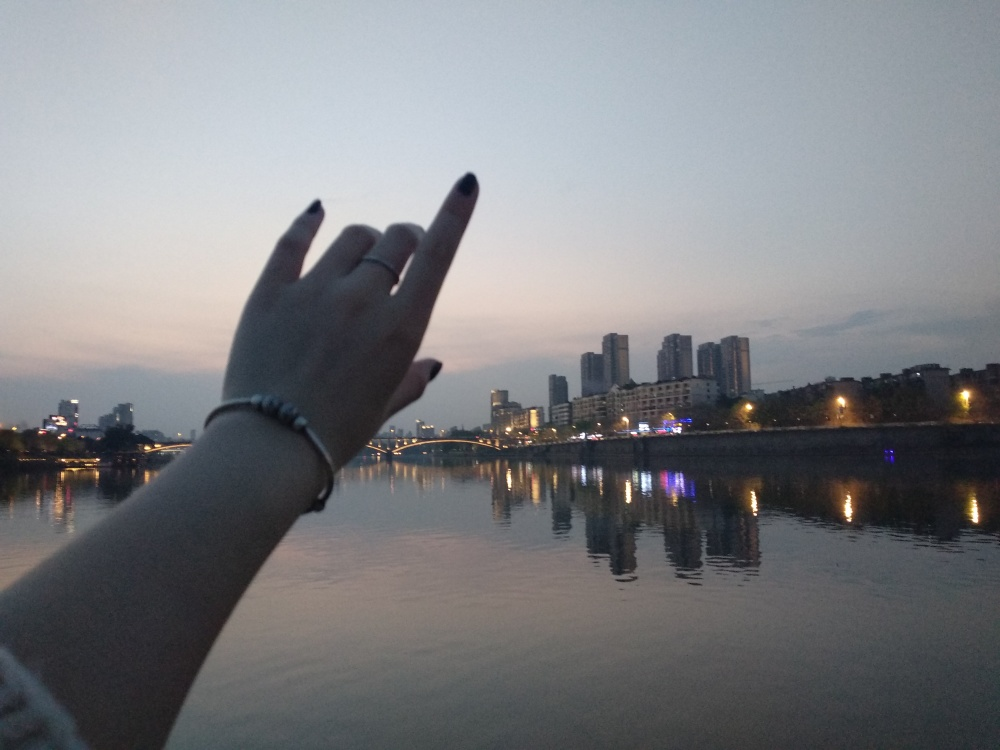Can you describe the mood or feeling evoked by this scene? The mood of the scene is tranquil and contemplative. The calm waters, the fading light, and the absence of visible people contribute to a sense of solitude and peace. There's also a touch of melancholy as the day gives way to night, and the world slowly transitions to a more introspective time. 